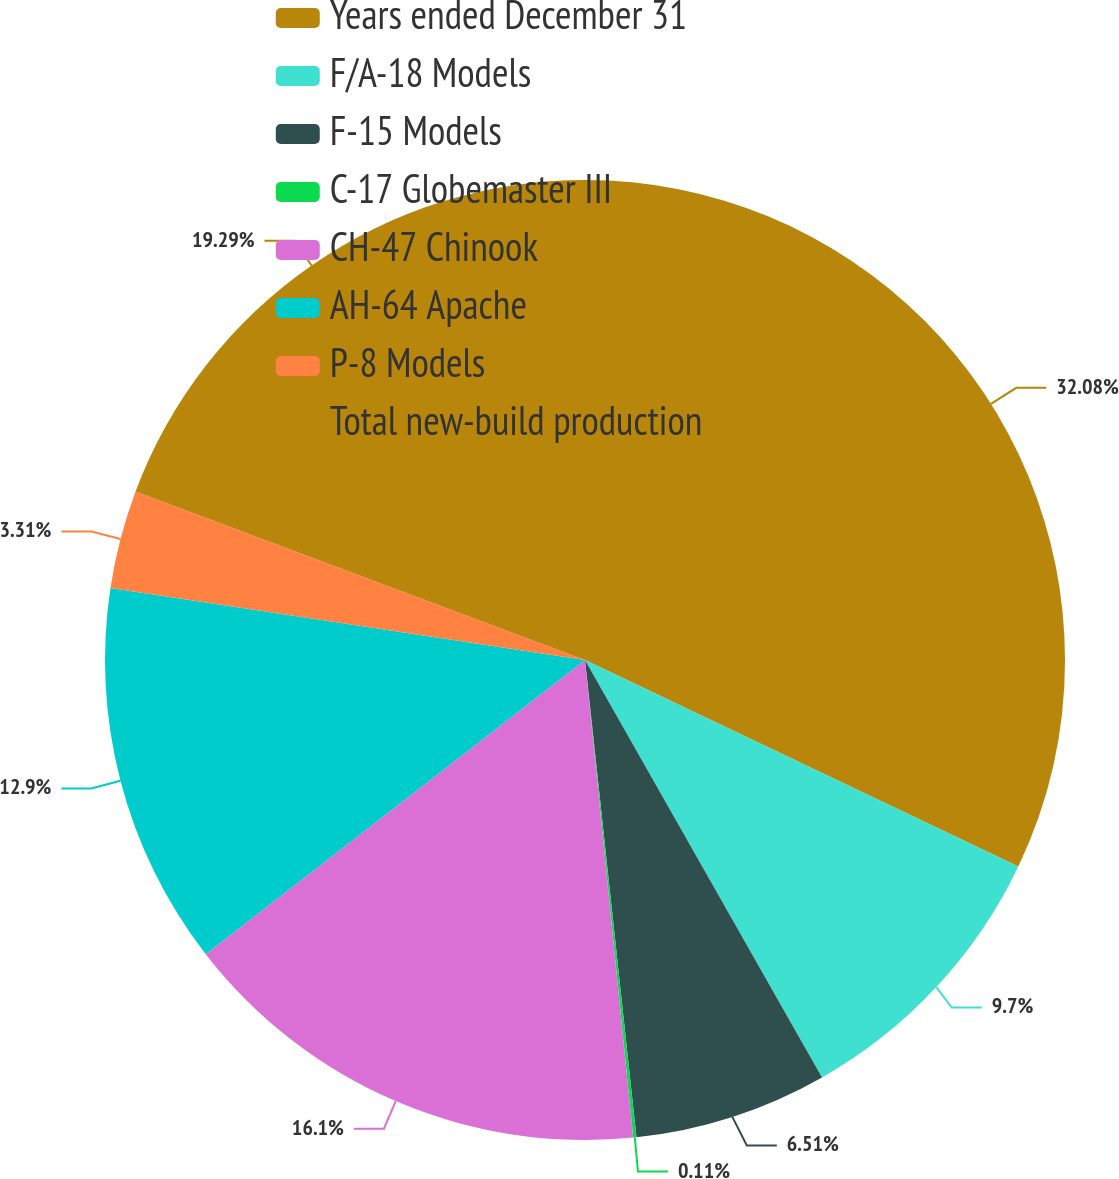Convert chart. <chart><loc_0><loc_0><loc_500><loc_500><pie_chart><fcel>Years ended December 31<fcel>F/A-18 Models<fcel>F-15 Models<fcel>C-17 Globemaster III<fcel>CH-47 Chinook<fcel>AH-64 Apache<fcel>P-8 Models<fcel>Total new-build production<nl><fcel>32.08%<fcel>9.7%<fcel>6.51%<fcel>0.11%<fcel>16.1%<fcel>12.9%<fcel>3.31%<fcel>19.29%<nl></chart> 